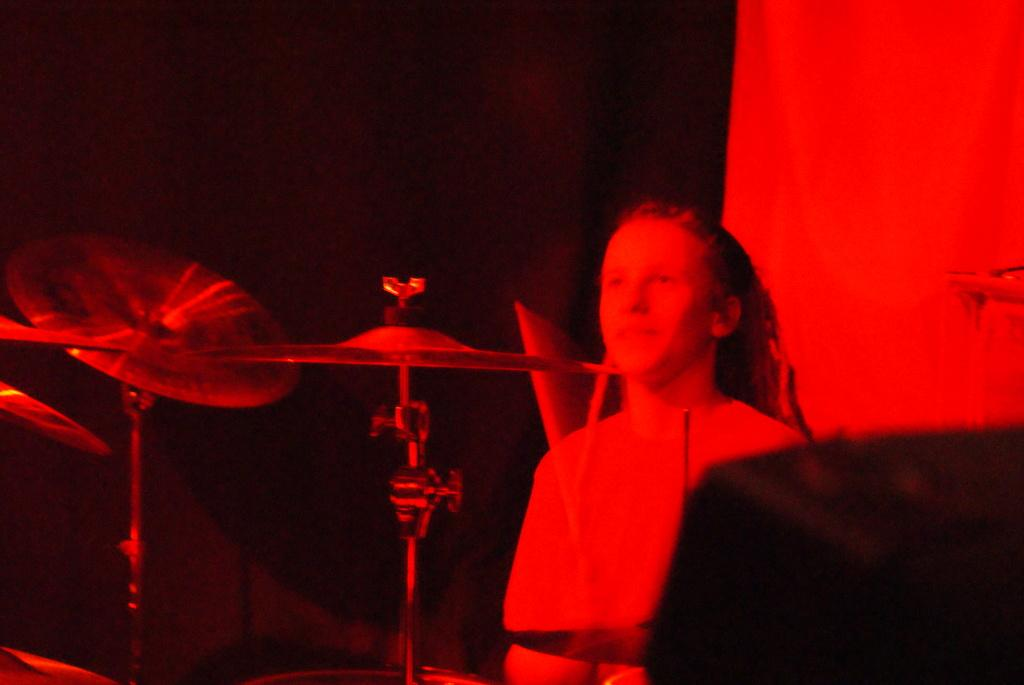What is the main subject of the image? The main subject of the image is a woman standing. What objects are also present in the image? There are musical drums in the image. What can be observed about the background of the image? The background of the image is dark. How does the woman in the image show her love for the house? There is no house present in the image, and the woman's feelings towards a house cannot be determined from the image. 